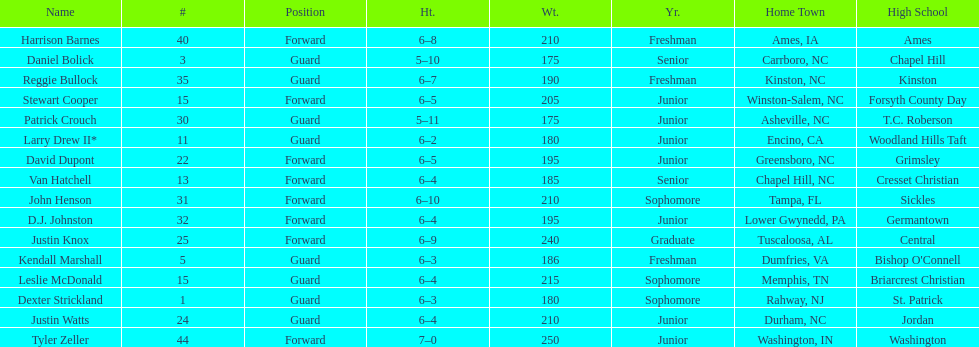How many players were taller than van hatchell? 7. 